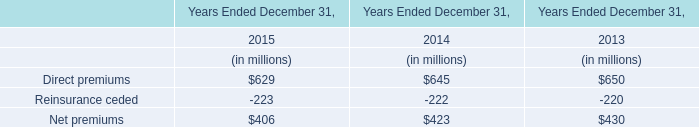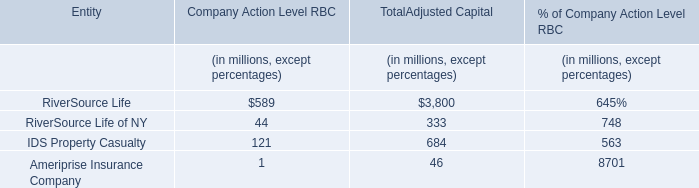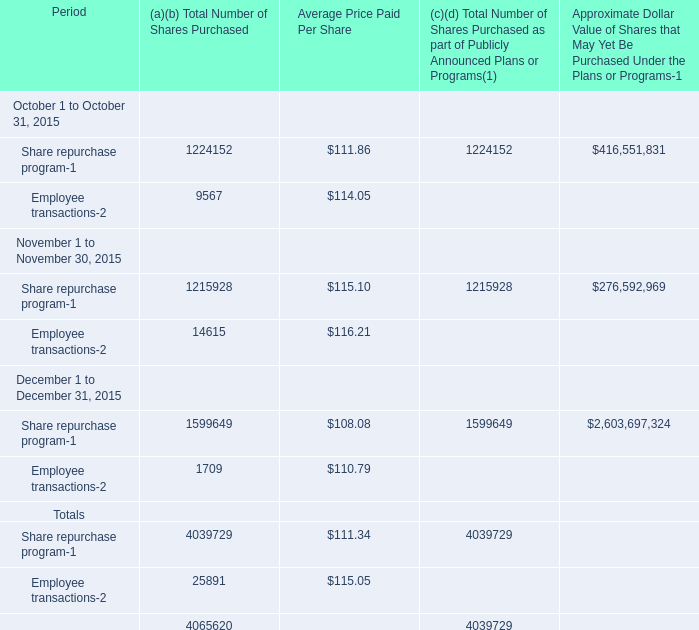In the month in the Fourth Quarter where Total Number of Shares Purchased for Share repurchase program is the most, what's the Total Number of Shares Purchased for Employee transactions? 
Answer: 1709. 